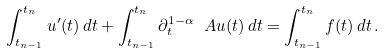Convert formula to latex. <formula><loc_0><loc_0><loc_500><loc_500>\int _ { t _ { n - 1 } } ^ { t _ { n } } u ^ { \prime } ( t ) \, d t + \int _ { t _ { n - 1 } } ^ { t _ { n } } \partial _ { t } ^ { 1 - \alpha } \ A u ( t ) \, d t = \int _ { t _ { n - 1 } } ^ { t _ { n } } f ( t ) \, d t \, .</formula> 